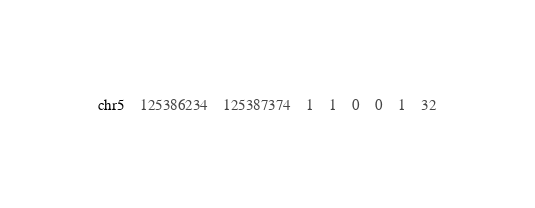Convert code to text. <code><loc_0><loc_0><loc_500><loc_500><_SQL_>chr5	125386234	125387374	1	1	0	0	1	32</code> 